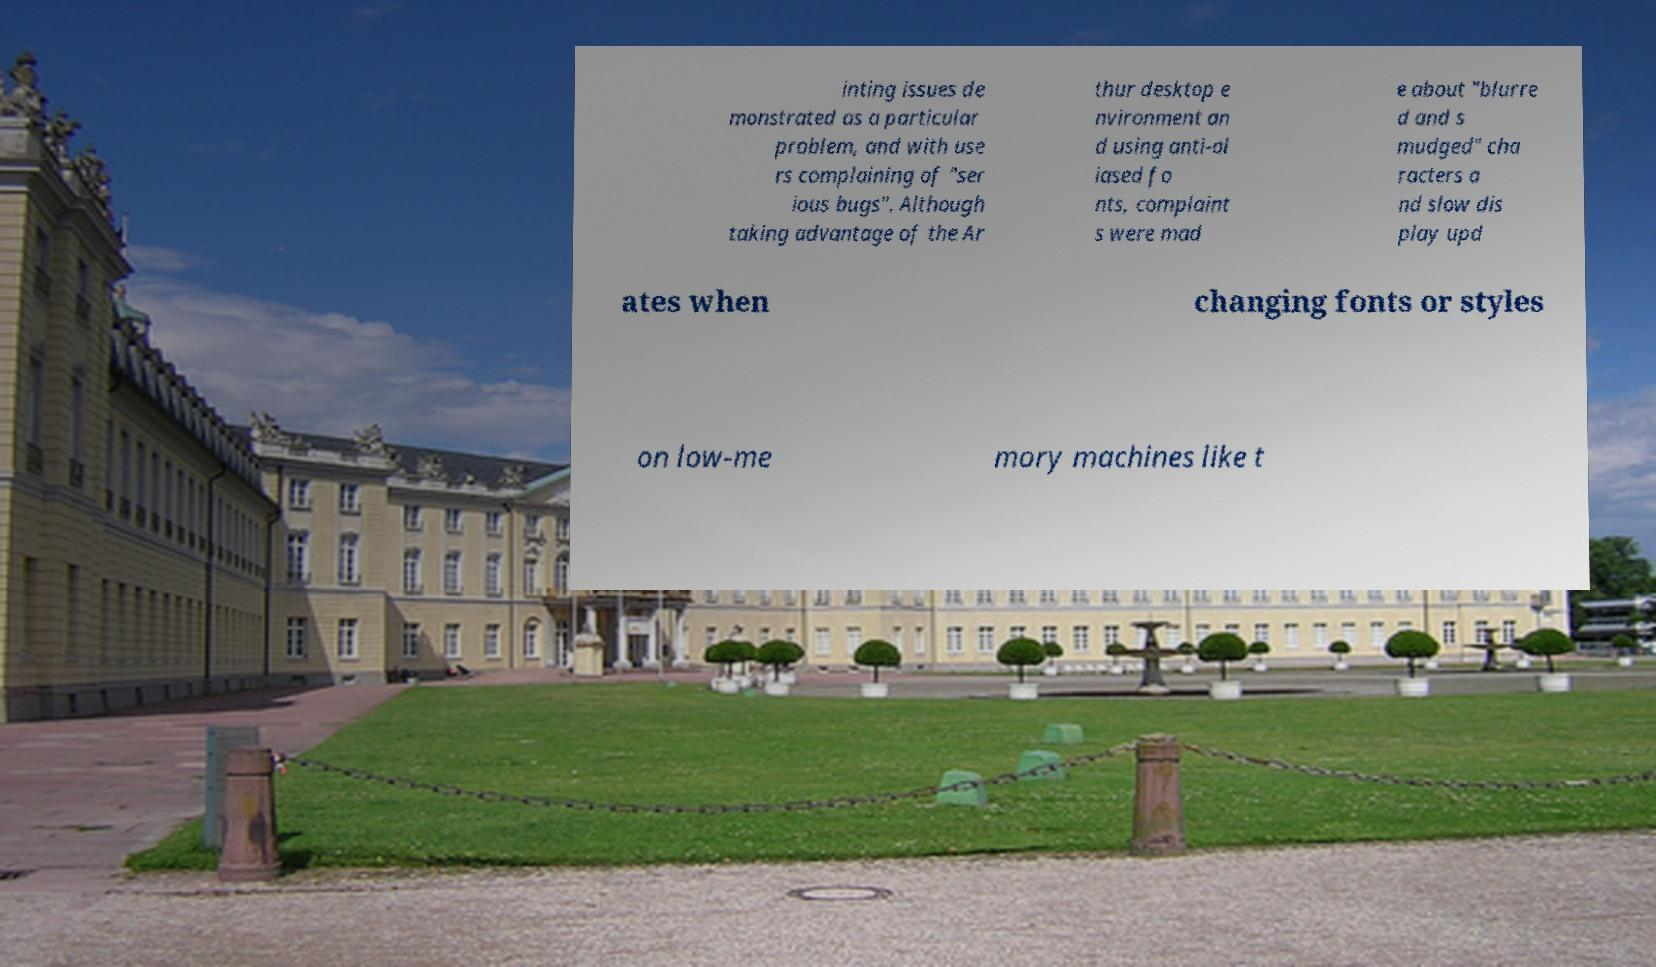Please identify and transcribe the text found in this image. inting issues de monstrated as a particular problem, and with use rs complaining of "ser ious bugs". Although taking advantage of the Ar thur desktop e nvironment an d using anti-al iased fo nts, complaint s were mad e about "blurre d and s mudged" cha racters a nd slow dis play upd ates when changing fonts or styles on low-me mory machines like t 